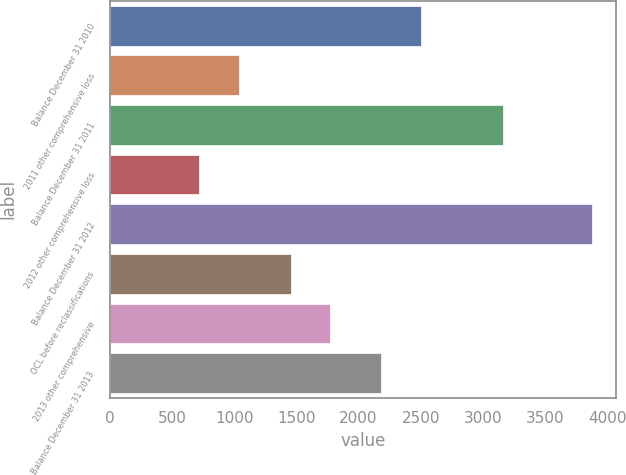Convert chart. <chart><loc_0><loc_0><loc_500><loc_500><bar_chart><fcel>Balance December 31 2010<fcel>2011 other comprehensive loss<fcel>Balance December 31 2011<fcel>2012 other comprehensive loss<fcel>Balance December 31 2012<fcel>OCL before reclassifications<fcel>2013 other comprehensive<fcel>Balance December 31 2013<nl><fcel>2499.2<fcel>1034.2<fcel>3162<fcel>718<fcel>3880<fcel>1453<fcel>1769.2<fcel>2183<nl></chart> 